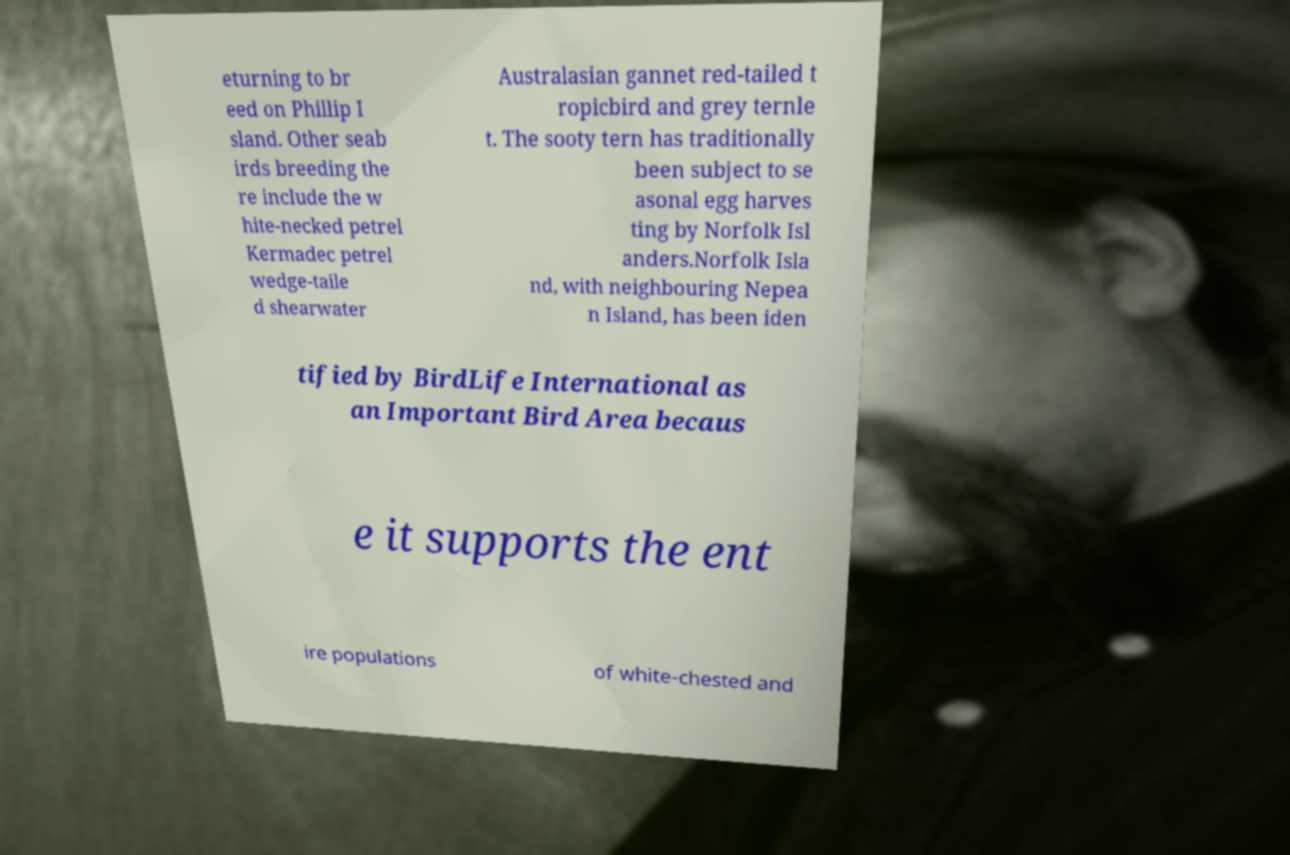Please identify and transcribe the text found in this image. eturning to br eed on Phillip I sland. Other seab irds breeding the re include the w hite-necked petrel Kermadec petrel wedge-taile d shearwater Australasian gannet red-tailed t ropicbird and grey ternle t. The sooty tern has traditionally been subject to se asonal egg harves ting by Norfolk Isl anders.Norfolk Isla nd, with neighbouring Nepea n Island, has been iden tified by BirdLife International as an Important Bird Area becaus e it supports the ent ire populations of white-chested and 